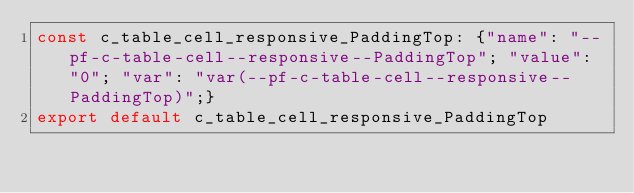Convert code to text. <code><loc_0><loc_0><loc_500><loc_500><_TypeScript_>const c_table_cell_responsive_PaddingTop: {"name": "--pf-c-table-cell--responsive--PaddingTop"; "value": "0"; "var": "var(--pf-c-table-cell--responsive--PaddingTop)";}
export default c_table_cell_responsive_PaddingTop
</code> 